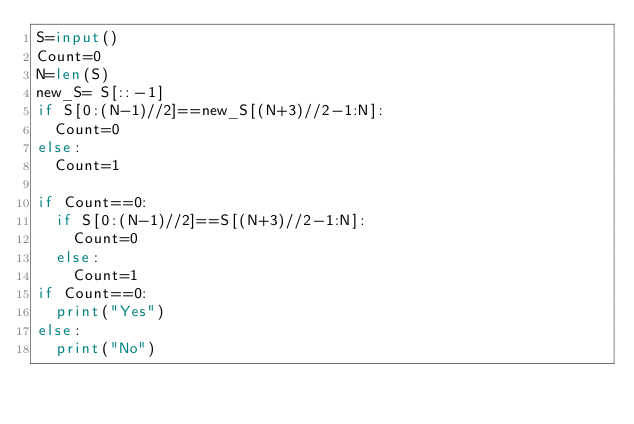<code> <loc_0><loc_0><loc_500><loc_500><_Python_>S=input()
Count=0
N=len(S)
new_S= S[::-1]
if S[0:(N-1)//2]==new_S[(N+3)//2-1:N]:
  Count=0
else:
  Count=1

if Count==0:
  if S[0:(N-1)//2]==S[(N+3)//2-1:N]:
    Count=0
  else:
    Count=1
if Count==0:
  print("Yes")
else:
  print("No")</code> 